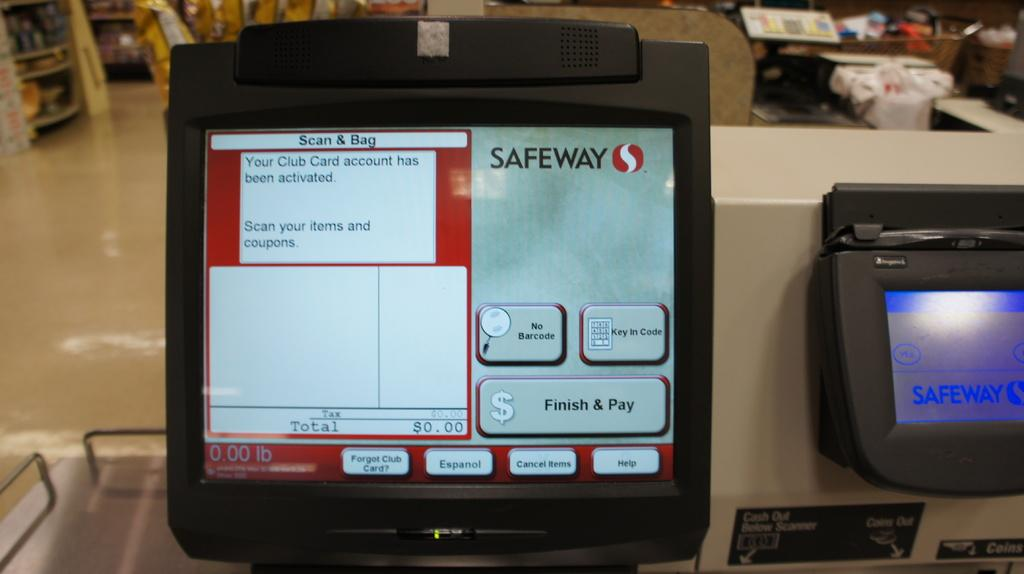<image>
Create a compact narrative representing the image presented. A safeway self checkout screen announces the club card has been activated and asks us to start scanning items. 